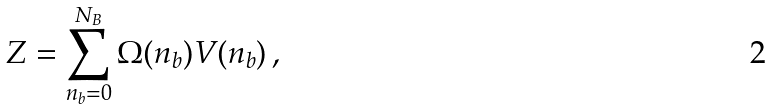Convert formula to latex. <formula><loc_0><loc_0><loc_500><loc_500>Z = \sum _ { n _ { b } = 0 } ^ { N _ { B } } \Omega ( n _ { b } ) V ( n _ { b } ) \, ,</formula> 